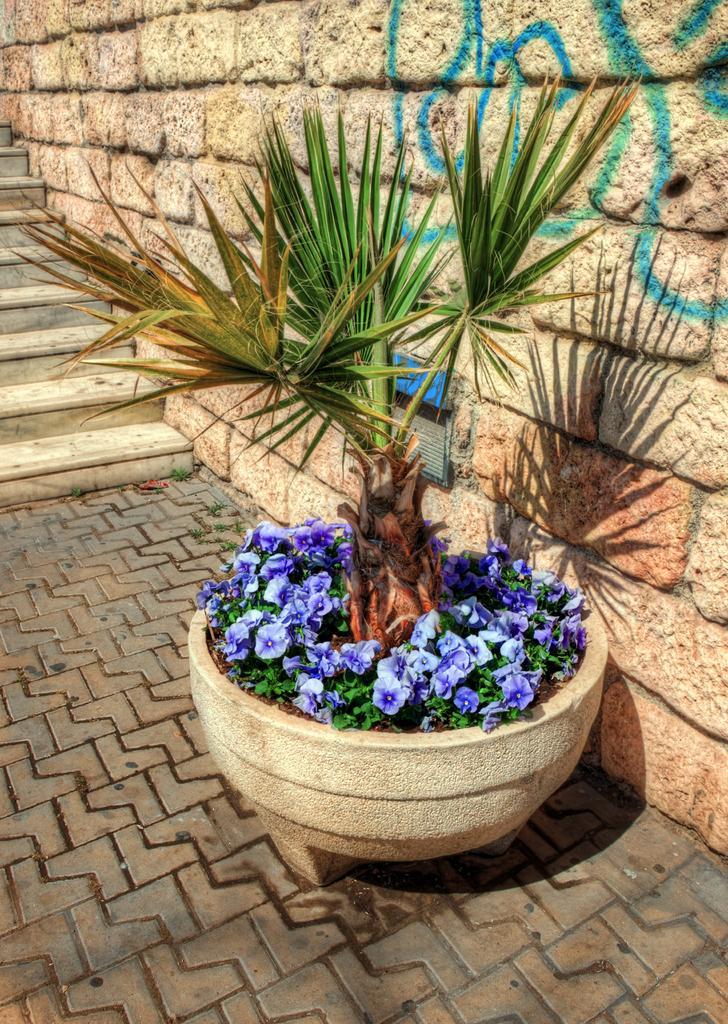Could you give a brief overview of what you see in this image? Here we can see a house plant in a pot on the floor and we can also see small plants with flowers in it. In the background we can see wall and drawings on it and on the left side we can see steps. 